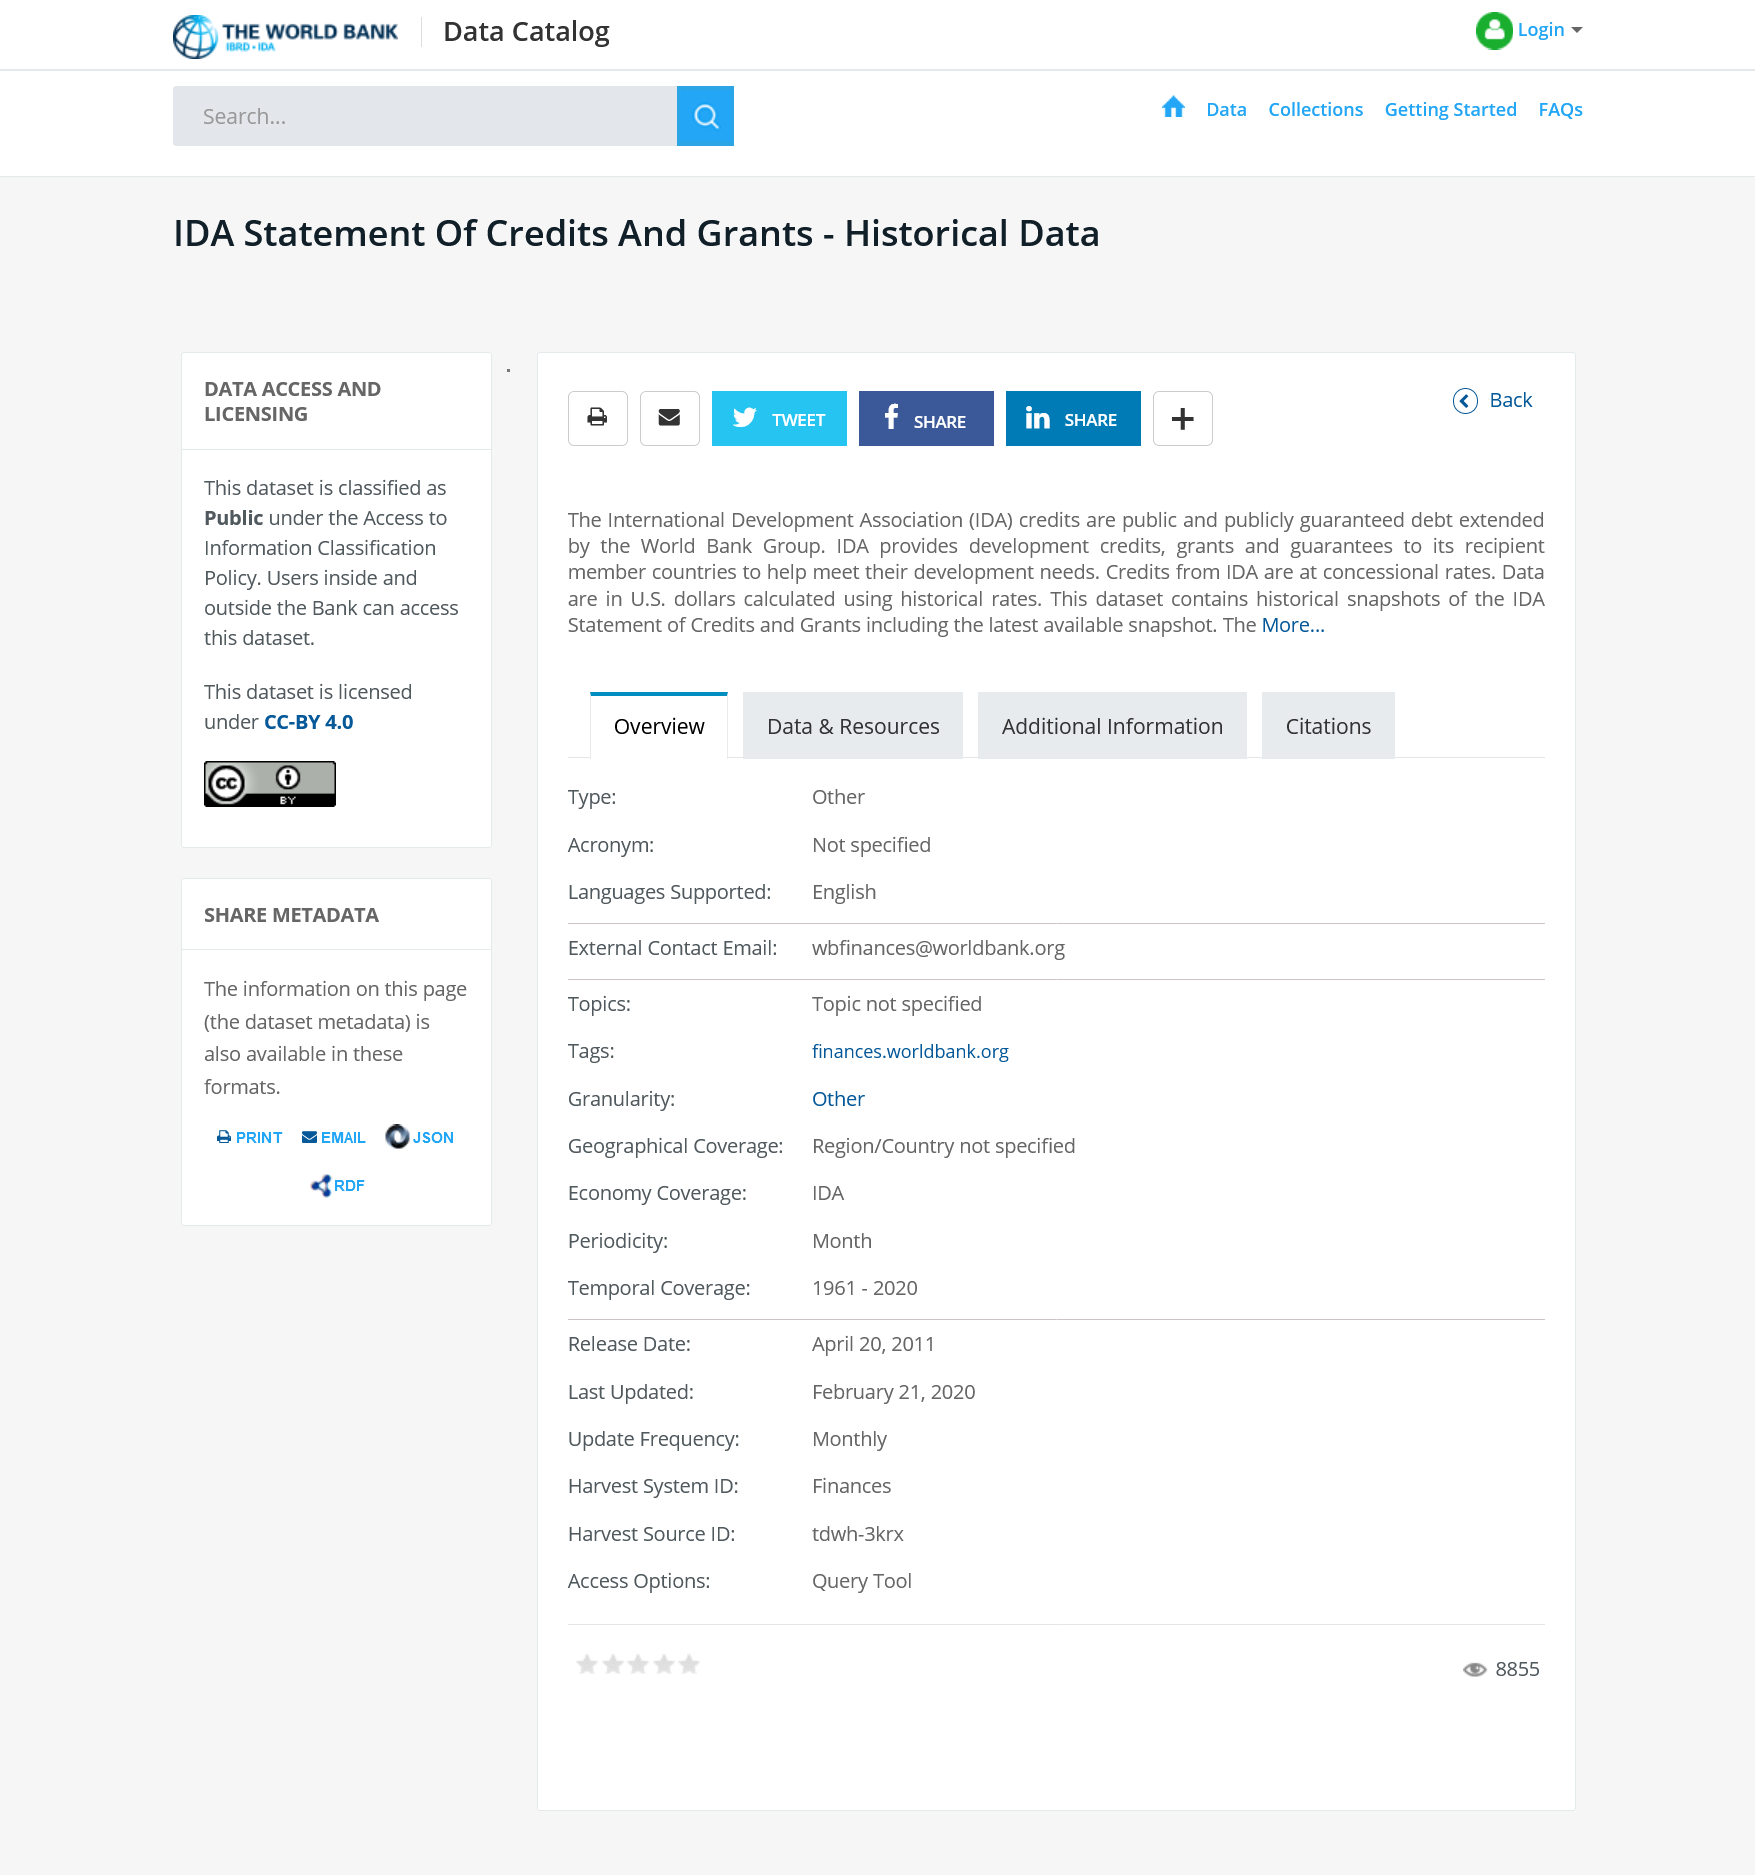Specify some key components in this picture. IDA stands for The International Development Association, which is an international financial institution that provides aid to developing countries. The article discusses U.S. dollars as the currency. Concessional credit is provided by the International Development Association, 